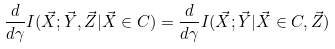<formula> <loc_0><loc_0><loc_500><loc_500>\frac { d } { d \gamma } I ( { \vec { X } } ; { \vec { Y } } , { \vec { Z } } | { \vec { X } } \in { C } ) = \frac { d } { d \gamma } I ( { \vec { X } } ; { \vec { Y } } | { \vec { X } } \in { C } , { \vec { Z } } )</formula> 